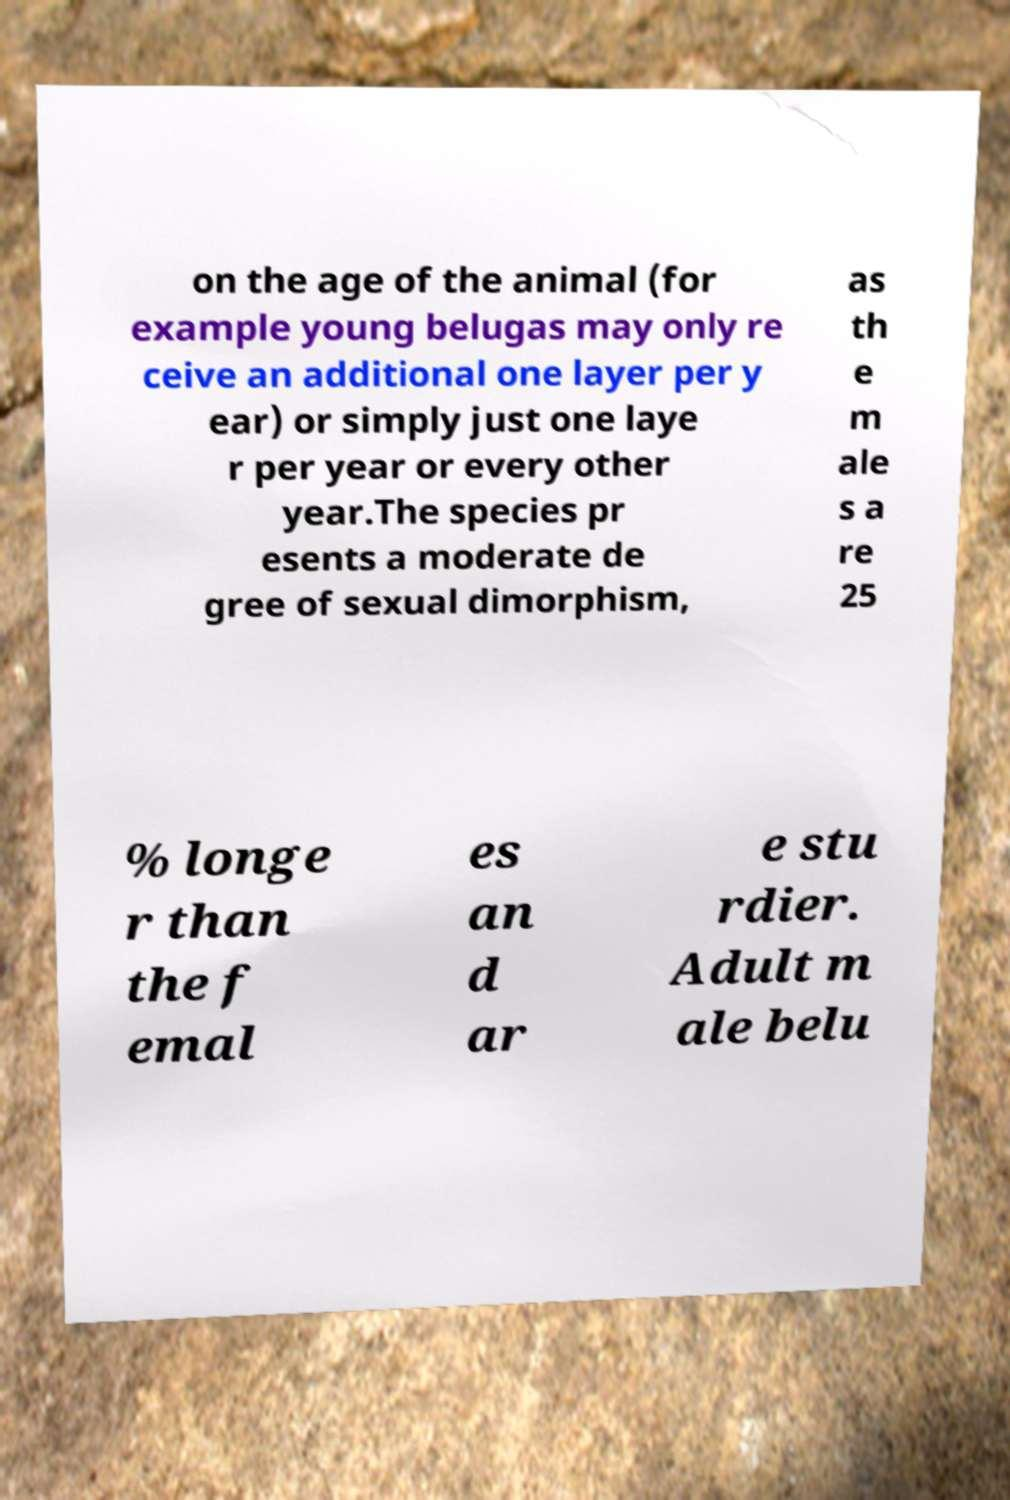I need the written content from this picture converted into text. Can you do that? on the age of the animal (for example young belugas may only re ceive an additional one layer per y ear) or simply just one laye r per year or every other year.The species pr esents a moderate de gree of sexual dimorphism, as th e m ale s a re 25 % longe r than the f emal es an d ar e stu rdier. Adult m ale belu 